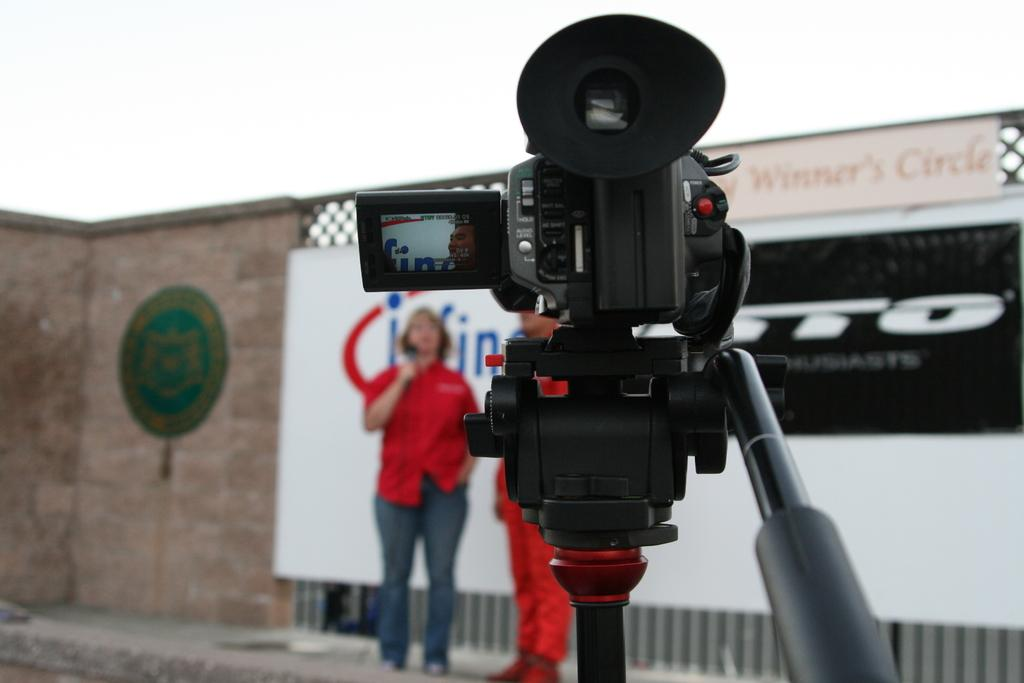What is the main subject in the center of the image? There is a camera in the center of the image. How is the camera positioned in the image? The camera is placed on a stand. What can be seen in the background of the image? There are people standing and a wall visible in the background of the image. What else is present in the image besides the camera and the people? There is a board visible in the image. What is visible at the top of the image? The sky is visible at the top of the image. What type of feast is being prepared in the image? There is no indication of a feast or any food preparation in the image. 